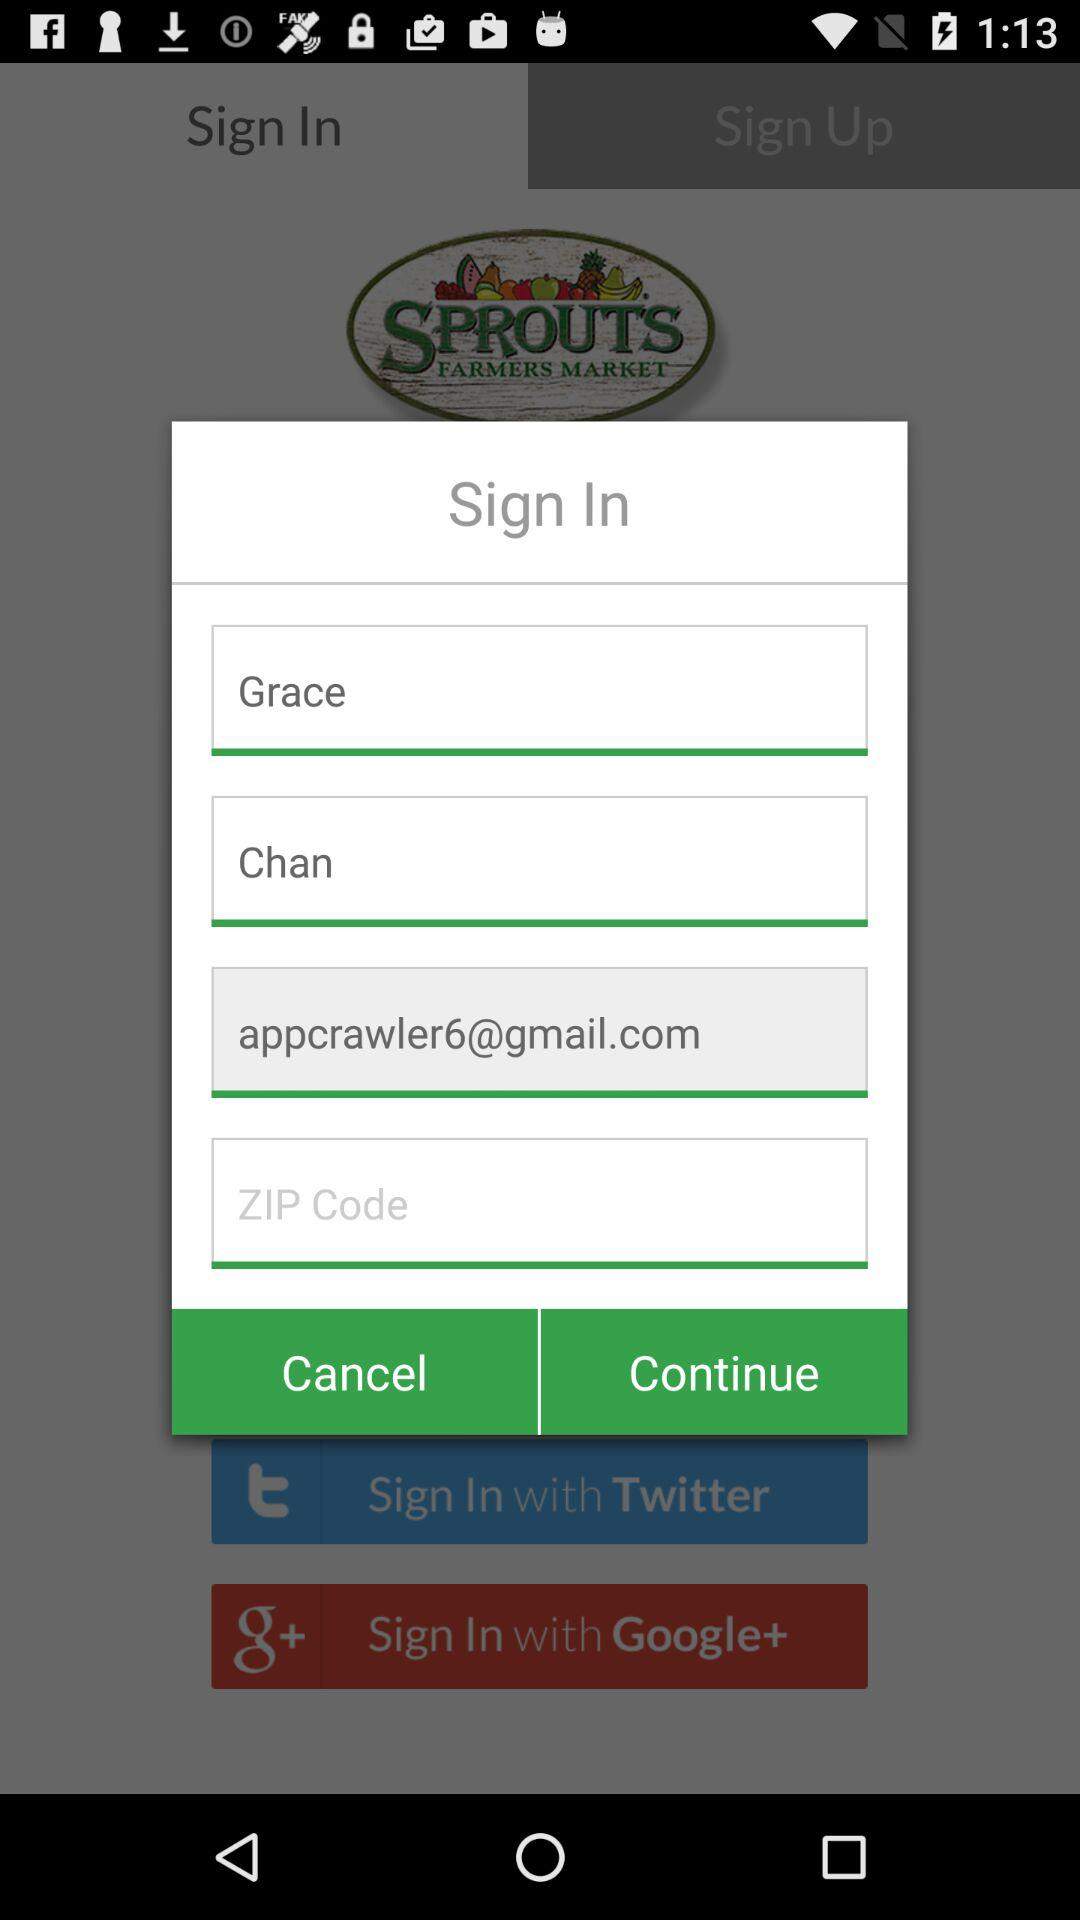Which applications can be used to sign in? The applications that can be used to sign in are "Twitter" and "Google+". 